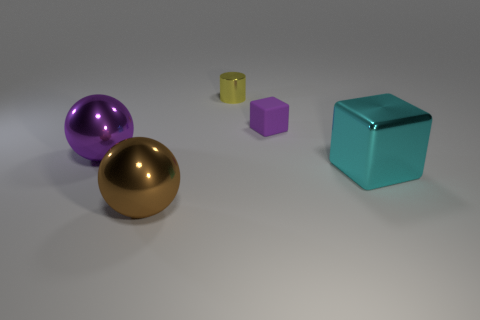Add 3 green metallic cylinders. How many objects exist? 8 Subtract all green cylinders. Subtract all gray spheres. How many cylinders are left? 1 Subtract all spheres. How many objects are left? 3 Add 5 small things. How many small things are left? 7 Add 3 red metallic spheres. How many red metallic spheres exist? 3 Subtract 0 green cylinders. How many objects are left? 5 Subtract all gray metal objects. Subtract all blocks. How many objects are left? 3 